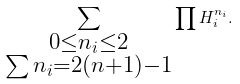Convert formula to latex. <formula><loc_0><loc_0><loc_500><loc_500>\sum _ { \substack { 0 \leq n _ { i } \leq 2 \\ \sum n _ { i } = 2 ( n + 1 ) - 1 } } \prod H _ { i } ^ { n _ { i } } .</formula> 